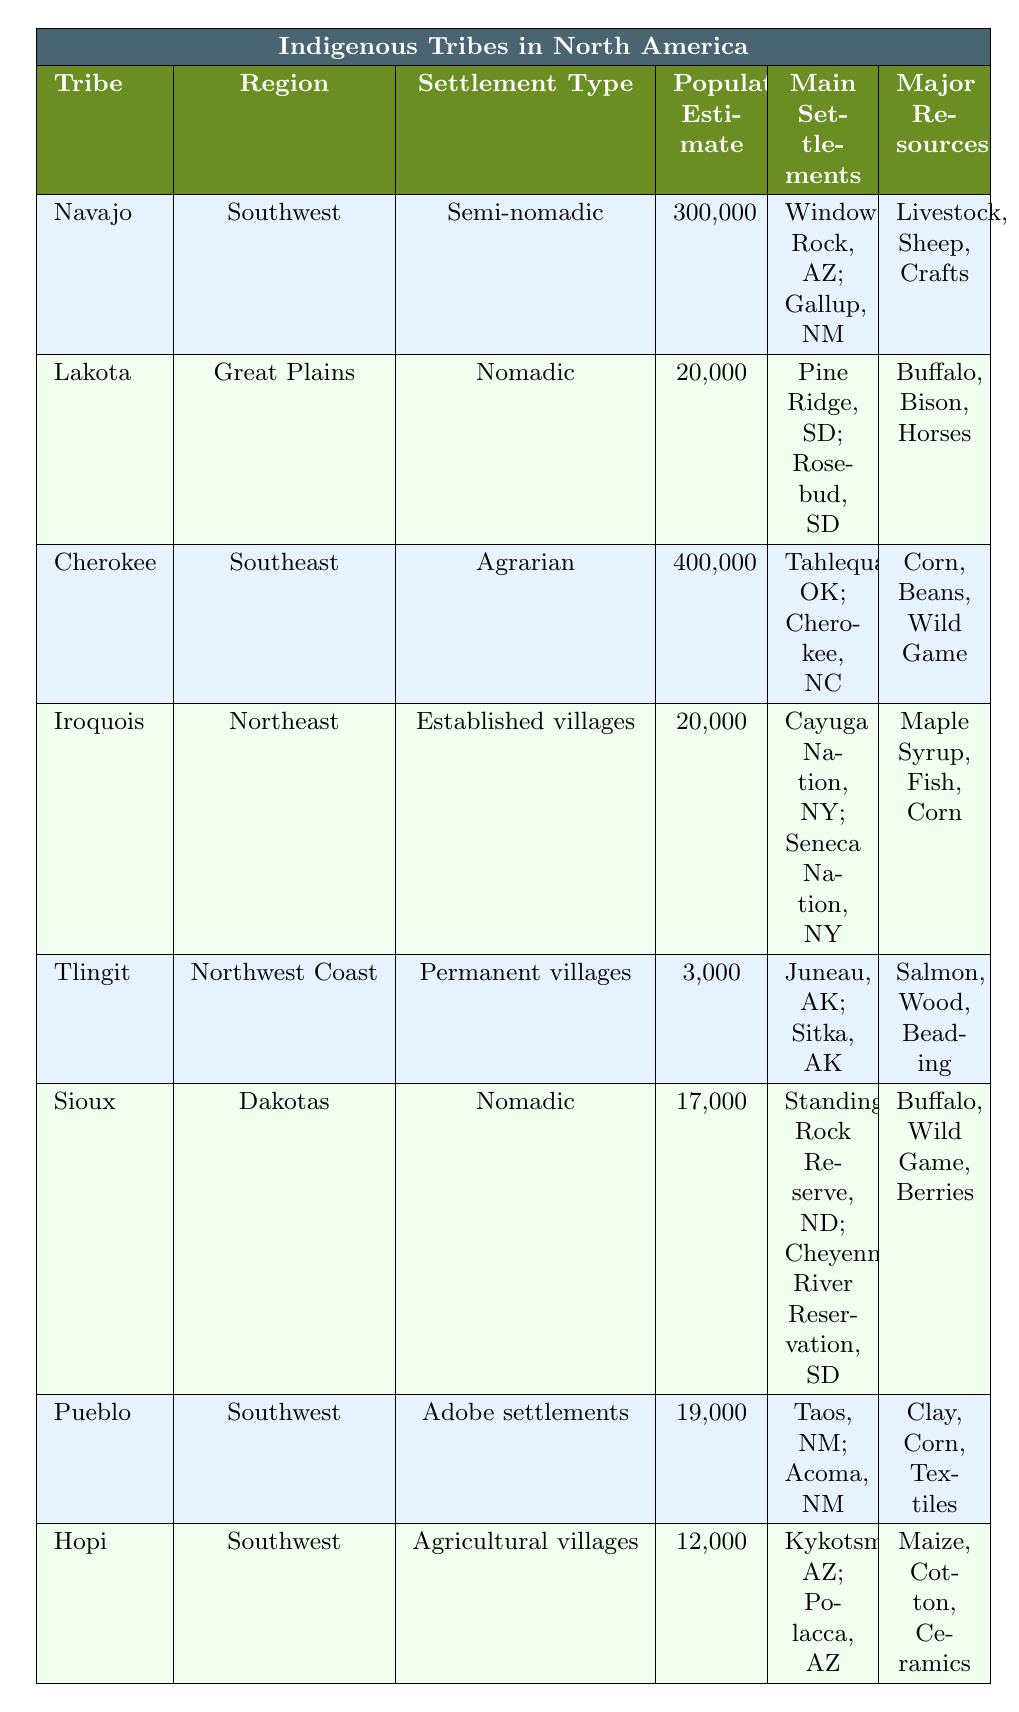What is the population estimate for the Cherokee tribe? The table lists the population estimate for the Cherokee tribe as 400,000 in the corresponding row.
Answer: 400,000 Which tribe has the largest population estimate? By comparing the population estimates provided, the Cherokee tribe has the highest estimate of 400,000.
Answer: Cherokee How many tribes have a population estimate below 20,000? The tribes with population estimates below 20,000 are Tlingit (3,000) and Pueblo (19,000); thus, there are two of them.
Answer: 2 What are the main settlements of the Navajo tribe? The main settlements for the Navajo tribe are listed as Window Rock, AZ, and Gallup, NM in the respective row.
Answer: Window Rock, AZ; Gallup, NM Is the settlement type of the Lakota tribe nomadic? The table indicates that the Lakota tribe's settlement type is marked as nomadic, confirming the statement is true.
Answer: Yes Which tribe has a greater population estimate, the Hopi or the Pueblo? The Hopi tribe has a population estimate of 12,000, while the Pueblo tribe has 19,000. Since 19,000 (Pueblo) is greater than 12,000 (Hopi), the Pueblo has a greater estimate.
Answer: Pueblo What are the major resources for the Iroquois tribe? The major resources listed for the Iroquois tribe include Maple Syrup, Fish, and Corn, as seen in the corresponding row.
Answer: Maple Syrup, Fish, Corn How does the population of the Sioux tribe compare to that of the Tlingit tribe? The Sioux tribe has a population of 17,000 while the Tlingit tribe has 3,000. Comparing these values, 17,000 is significantly higher than 3,000, indicating the Sioux has a larger population.
Answer: Sioux has a larger population If you combine the populations of the Navajo and Cherokee tribes, what would be the total? The populations are 300,000 (Navajo) and 400,000 (Cherokee). Their sum is calculated as 300,000 + 400,000 = 700,000, which gives the total population.
Answer: 700,000 Which region has tribes with both nomadic and semi-nomadic settlement types? By examining the table, the Southwest region has the Navajo (semi-nomadic) and Pueblo (Adobe settlements) but also has the Hopi, which is agrarian. The Great Plains has the Lakota and Sioux, both nomadic. Thus, the Great Plains region has nomadic tribes while the Southwest has semi-nomadic and agrarian tribes.
Answer: Great Plains has nomadic tribes; Southwest has semi-nomadic and agrarian What settlement type is unique to the Tlingit tribe? The Tlingit tribe's settlement type is identified as permanent villages, which distinguishes it from the other tribes in the table.
Answer: Permanent villages 